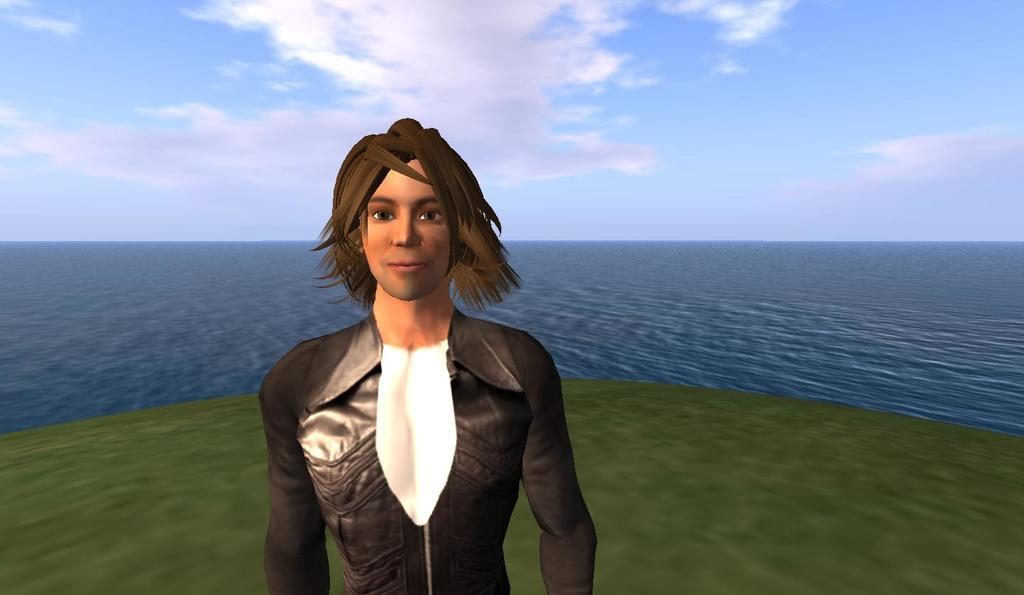What type of element is present in the image? There is a digital element in the image. Can you describe the person in the image? The person in the image is wearing a white and black dress. What can be seen in the background of the image? There is grass, water, and the sky visible in the background of the image. How many bulbs are hanging from the tree in the image? There is no tree or bulbs present in the image. What type of flower is growing near the water in the image? There are no flowers visible in the image. 